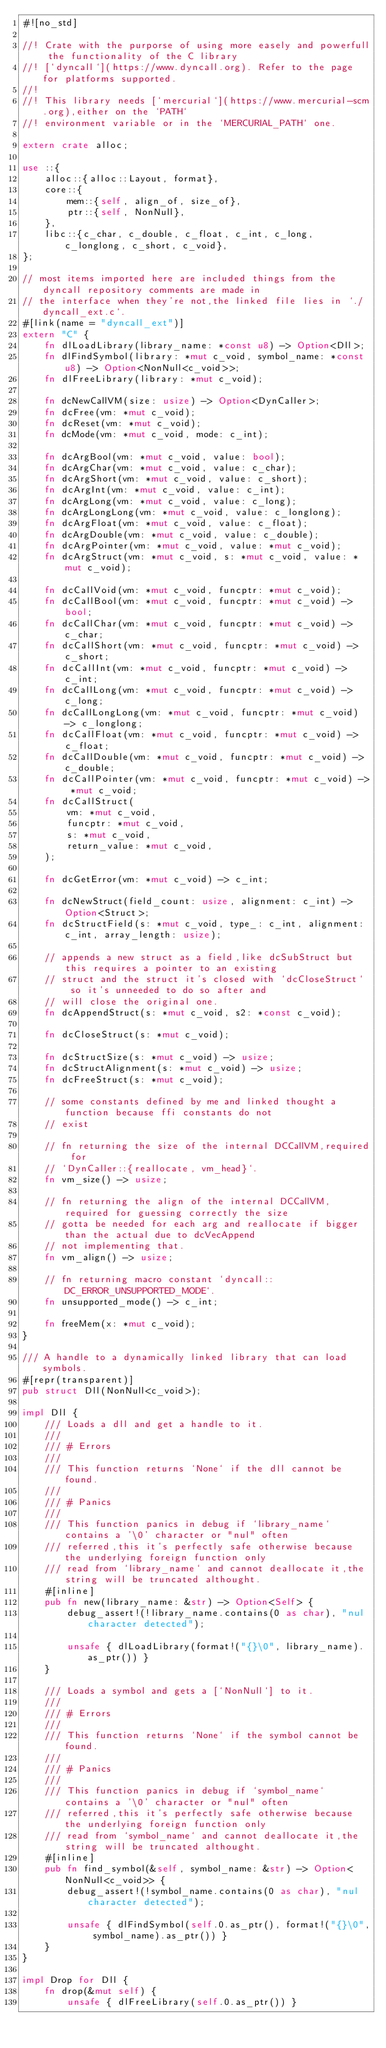Convert code to text. <code><loc_0><loc_0><loc_500><loc_500><_Rust_>#![no_std]

//! Crate with the purporse of using more easely and powerfull the functionality of the C library
//! [`dyncall`](https://www.dyncall.org). Refer to the page for platforms supported.
//!
//! This library needs [`mercurial`](https://www.mercurial-scm.org),either on the `PATH`
//! environment variable or in the `MERCURIAL_PATH` one.

extern crate alloc;

use ::{
    alloc::{alloc::Layout, format},
    core::{
        mem::{self, align_of, size_of},
        ptr::{self, NonNull},
    },
    libc::{c_char, c_double, c_float, c_int, c_long, c_longlong, c_short, c_void},
};

// most items imported here are included things from the dyncall repository comments are made in
// the interface when they're not,the linked file lies in `./dyncall_ext.c`.
#[link(name = "dyncall_ext")]
extern "C" {
    fn dlLoadLibrary(library_name: *const u8) -> Option<Dll>;
    fn dlFindSymbol(library: *mut c_void, symbol_name: *const u8) -> Option<NonNull<c_void>>;
    fn dlFreeLibrary(library: *mut c_void);

    fn dcNewCallVM(size: usize) -> Option<DynCaller>;
    fn dcFree(vm: *mut c_void);
    fn dcReset(vm: *mut c_void);
    fn dcMode(vm: *mut c_void, mode: c_int);

    fn dcArgBool(vm: *mut c_void, value: bool);
    fn dcArgChar(vm: *mut c_void, value: c_char);
    fn dcArgShort(vm: *mut c_void, value: c_short);
    fn dcArgInt(vm: *mut c_void, value: c_int);
    fn dcArgLong(vm: *mut c_void, value: c_long);
    fn dcArgLongLong(vm: *mut c_void, value: c_longlong);
    fn dcArgFloat(vm: *mut c_void, value: c_float);
    fn dcArgDouble(vm: *mut c_void, value: c_double);
    fn dcArgPointer(vm: *mut c_void, value: *mut c_void);
    fn dcArgStruct(vm: *mut c_void, s: *mut c_void, value: *mut c_void);

    fn dcCallVoid(vm: *mut c_void, funcptr: *mut c_void);
    fn dcCallBool(vm: *mut c_void, funcptr: *mut c_void) -> bool;
    fn dcCallChar(vm: *mut c_void, funcptr: *mut c_void) -> c_char;
    fn dcCallShort(vm: *mut c_void, funcptr: *mut c_void) -> c_short;
    fn dcCallInt(vm: *mut c_void, funcptr: *mut c_void) -> c_int;
    fn dcCallLong(vm: *mut c_void, funcptr: *mut c_void) -> c_long;
    fn dcCallLongLong(vm: *mut c_void, funcptr: *mut c_void) -> c_longlong;
    fn dcCallFloat(vm: *mut c_void, funcptr: *mut c_void) -> c_float;
    fn dcCallDouble(vm: *mut c_void, funcptr: *mut c_void) -> c_double;
    fn dcCallPointer(vm: *mut c_void, funcptr: *mut c_void) -> *mut c_void;
    fn dcCallStruct(
        vm: *mut c_void,
        funcptr: *mut c_void,
        s: *mut c_void,
        return_value: *mut c_void,
    );

    fn dcGetError(vm: *mut c_void) -> c_int;

    fn dcNewStruct(field_count: usize, alignment: c_int) -> Option<Struct>;
    fn dcStructField(s: *mut c_void, type_: c_int, alignment: c_int, array_length: usize);

    // appends a new struct as a field,like dcSubStruct but this requires a pointer to an existing
    // struct and the struct it's closed with `dcCloseStruct`  so it's unneeded to do so after and
    // will close the original one.
    fn dcAppendStruct(s: *mut c_void, s2: *const c_void);

    fn dcCloseStruct(s: *mut c_void);

    fn dcStructSize(s: *mut c_void) -> usize;
    fn dcStructAlignment(s: *mut c_void) -> usize;
    fn dcFreeStruct(s: *mut c_void);

    // some constants defined by me and linked thought a function because ffi constants do not
    // exist

    // fn returning the size of the internal DCCallVM,required for
    // `DynCaller::{reallocate, vm_head}`.
    fn vm_size() -> usize;

    // fn returning the align of the internal DCCallVM,required for guessing correctly the size
    // gotta be needed for each arg and reallocate if bigger than the actual due to dcVecAppend
    // not implementing that.
    fn vm_align() -> usize;

    // fn returning macro constant `dyncall::DC_ERROR_UNSUPPORTED_MODE`.
    fn unsupported_mode() -> c_int;

    fn freeMem(x: *mut c_void);
}

/// A handle to a dynamically linked library that can load symbols.
#[repr(transparent)]
pub struct Dll(NonNull<c_void>);

impl Dll {
    /// Loads a dll and get a handle to it.
    ///
    /// # Errors
    ///
    /// This function returns `None` if the dll cannot be found.
    ///
    /// # Panics
    ///
    /// This function panics in debug if `library_name` contains a '\0' character or "nul" often
    /// referred,this it's perfectly safe otherwise because the underlying foreign function only
    /// read from `library_name` and cannot deallocate it,the string will be truncated althought.
    #[inline]
    pub fn new(library_name: &str) -> Option<Self> {
        debug_assert!(!library_name.contains(0 as char), "nul character detected");

        unsafe { dlLoadLibrary(format!("{}\0", library_name).as_ptr()) }
    }

    /// Loads a symbol and gets a [`NonNull`] to it.
    ///
    /// # Errors
    ///
    /// This function returns `None` if the symbol cannot be found.
    ///
    /// # Panics
    ///
    /// This function panics in debug if `symbol_name` contains a '\0' character or "nul" often
    /// referred,this it's perfectly safe otherwise because the underlying foreign function only
    /// read from `symbol_name` and cannot deallocate it,the string will be truncated althought.
    #[inline]
    pub fn find_symbol(&self, symbol_name: &str) -> Option<NonNull<c_void>> {
        debug_assert!(!symbol_name.contains(0 as char), "nul character detected");

        unsafe { dlFindSymbol(self.0.as_ptr(), format!("{}\0", symbol_name).as_ptr()) }
    }
}

impl Drop for Dll {
    fn drop(&mut self) {
        unsafe { dlFreeLibrary(self.0.as_ptr()) }</code> 